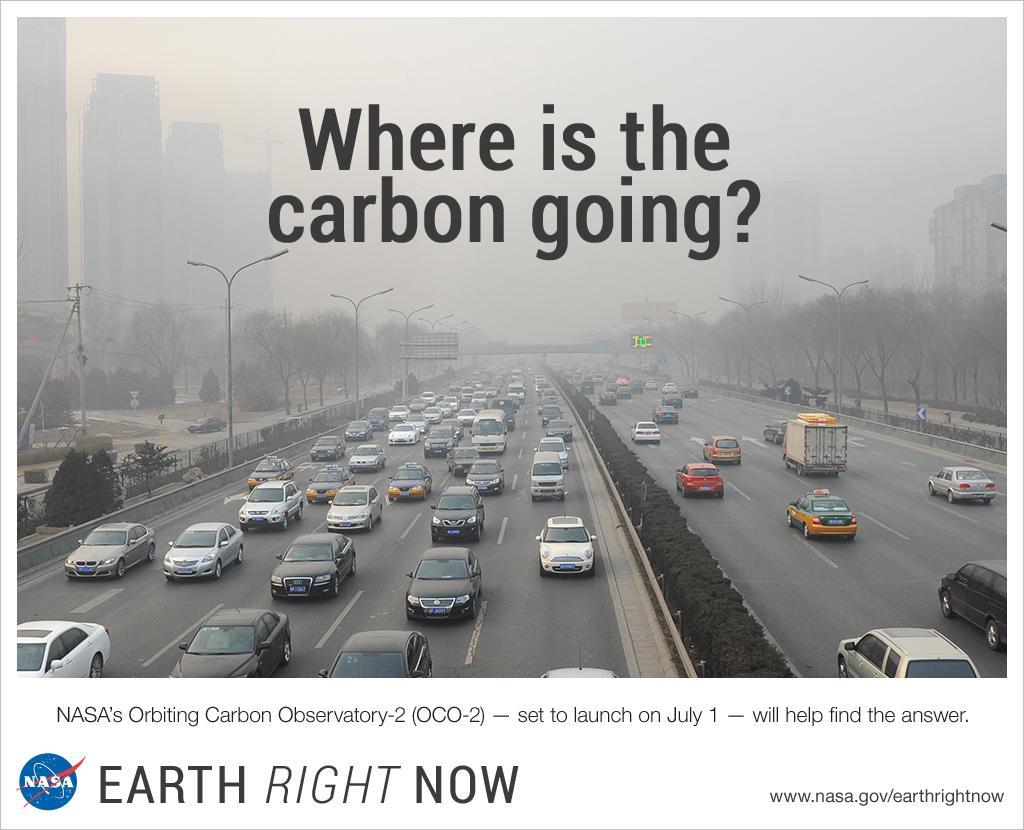Could you give a brief overview of what you see in this image? This is a poster. In this poster there is something written. In the left bottom corner there is a logo. Also there is an image with roads. On the roads there are many vehicles. On the sides of the road there are light poles, trees and buildings. Middle of the road there are bushes. 